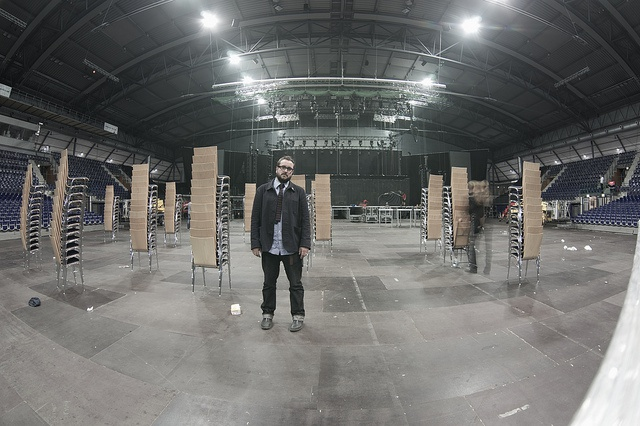Describe the objects in this image and their specific colors. I can see chair in black, darkgray, and gray tones, people in black, gray, and darkgray tones, chair in black, darkgray, and gray tones, chair in black, darkgray, and gray tones, and chair in black, gray, and darkgray tones in this image. 